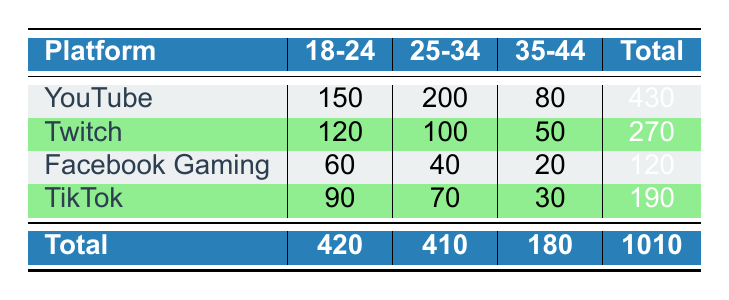What is the total preference count for YouTube? The total preference count for YouTube can be found in the 'Total' column corresponding to YouTube, which is 430.
Answer: 430 Which platform has the highest preference count for the age group 25-34? To find this, we look at the values for age group 25-34. YouTube has 200, Twitch has 100, Facebook Gaming has 40, and TikTok has 70. The highest value is from YouTube.
Answer: YouTube What is the total preference count for all platforms combined in the age group 18-24? To find the total for age group 18-24, we add the preference counts: YouTube (150) + Twitch (120) + Facebook Gaming (60) + TikTok (90) = 420.
Answer: 420 Is the preference for Twitch greater than the combined preferences for Facebook Gaming and TikTok for the 35-44 age group? First, we need the preference for Twitch, which is 50. Then we add Facebook Gaming (20) and TikTok (30), giving us a total of 50. Since Twitch’s preference (50) is equal to the combined total of Facebook Gaming and TikTok (50), the answer is no.
Answer: No What is the difference between the preference counts for the age group 18-24 between YouTube and Facebook Gaming? We take the preference count for YouTube (150) and subtract the count for Facebook Gaming (60). The difference is 150 - 60 = 90.
Answer: 90 Does the platform TikTok have more total preferences than Twitch? TikTok has a total of 190 preferences, while Twitch has a total of 270 preferences. Since 190 is less than 270, the answer is no.
Answer: No What is the average preference count for the age group 35-44 across all platforms? The preference counts for age group 35-44 are: YouTube (80), Twitch (50), Facebook Gaming (20), TikTok (30). We sum them up: 80 + 50 + 20 + 30 = 180. There are 4 data points, so the average is 180/4 = 45.
Answer: 45 Which age group has the lowest total preference count across all platforms? We need to look at the total counts for each age group: 18-24 (420), 25-34 (410), and 35-44 (180). The lowest total is for age group 35-44.
Answer: 35-44 What is the preference count for Facebook Gaming in the age group 25-34? The preference count for Facebook Gaming in the age group 25-34 is listed directly in the table, which is 40.
Answer: 40 